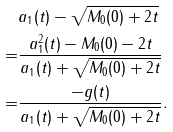<formula> <loc_0><loc_0><loc_500><loc_500>& a _ { 1 } ( t ) - \sqrt { M _ { 0 } ( 0 ) + 2 t } \\ = & \frac { a _ { 1 } ^ { 2 } ( t ) - M _ { 0 } ( 0 ) - 2 t } { a _ { 1 } ( t ) + \sqrt { M _ { 0 } ( 0 ) + 2 t } } \\ = & \frac { - g ( t ) } { a _ { 1 } ( t ) + \sqrt { M _ { 0 } ( 0 ) + 2 t } } .</formula> 